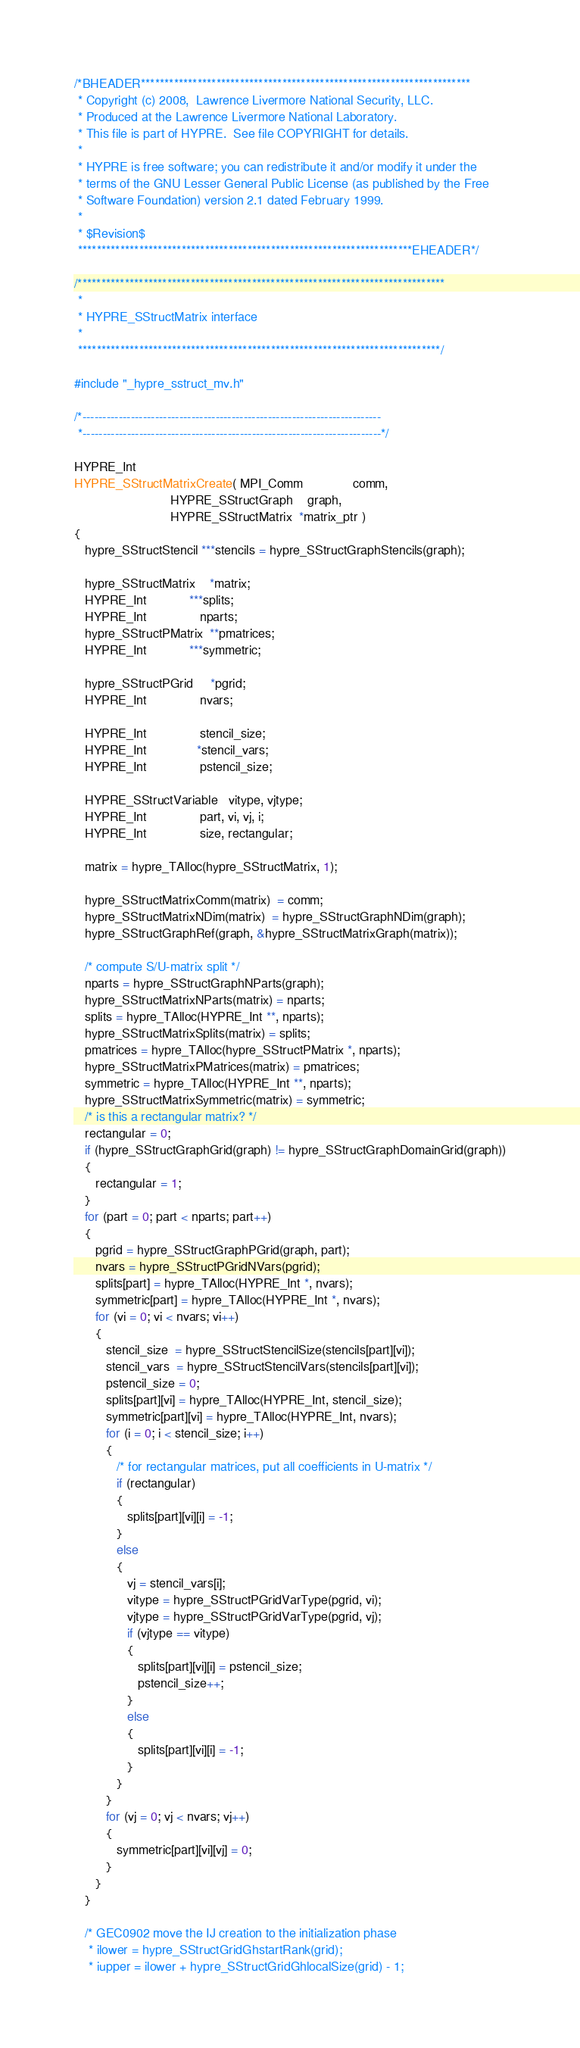Convert code to text. <code><loc_0><loc_0><loc_500><loc_500><_C_>/*BHEADER**********************************************************************
 * Copyright (c) 2008,  Lawrence Livermore National Security, LLC.
 * Produced at the Lawrence Livermore National Laboratory.
 * This file is part of HYPRE.  See file COPYRIGHT for details.
 *
 * HYPRE is free software; you can redistribute it and/or modify it under the
 * terms of the GNU Lesser General Public License (as published by the Free
 * Software Foundation) version 2.1 dated February 1999.
 *
 * $Revision$
 ***********************************************************************EHEADER*/

/******************************************************************************
 *
 * HYPRE_SStructMatrix interface
 *
 *****************************************************************************/

#include "_hypre_sstruct_mv.h"

/*--------------------------------------------------------------------------
 *--------------------------------------------------------------------------*/

HYPRE_Int
HYPRE_SStructMatrixCreate( MPI_Comm              comm,
                           HYPRE_SStructGraph    graph,
                           HYPRE_SStructMatrix  *matrix_ptr )
{
   hypre_SStructStencil ***stencils = hypre_SStructGraphStencils(graph);

   hypre_SStructMatrix    *matrix;
   HYPRE_Int            ***splits;
   HYPRE_Int               nparts;
   hypre_SStructPMatrix  **pmatrices;
   HYPRE_Int            ***symmetric;

   hypre_SStructPGrid     *pgrid;
   HYPRE_Int               nvars;

   HYPRE_Int               stencil_size;
   HYPRE_Int              *stencil_vars;
   HYPRE_Int               pstencil_size;

   HYPRE_SStructVariable   vitype, vjtype;
   HYPRE_Int               part, vi, vj, i;
   HYPRE_Int               size, rectangular;

   matrix = hypre_TAlloc(hypre_SStructMatrix, 1);

   hypre_SStructMatrixComm(matrix)  = comm;
   hypre_SStructMatrixNDim(matrix)  = hypre_SStructGraphNDim(graph);
   hypre_SStructGraphRef(graph, &hypre_SStructMatrixGraph(matrix));

   /* compute S/U-matrix split */
   nparts = hypre_SStructGraphNParts(graph);
   hypre_SStructMatrixNParts(matrix) = nparts;
   splits = hypre_TAlloc(HYPRE_Int **, nparts);
   hypre_SStructMatrixSplits(matrix) = splits;
   pmatrices = hypre_TAlloc(hypre_SStructPMatrix *, nparts);
   hypre_SStructMatrixPMatrices(matrix) = pmatrices;
   symmetric = hypre_TAlloc(HYPRE_Int **, nparts);
   hypre_SStructMatrixSymmetric(matrix) = symmetric;
   /* is this a rectangular matrix? */
   rectangular = 0;
   if (hypre_SStructGraphGrid(graph) != hypre_SStructGraphDomainGrid(graph))
   {
      rectangular = 1;
   }
   for (part = 0; part < nparts; part++)
   {
      pgrid = hypre_SStructGraphPGrid(graph, part);
      nvars = hypre_SStructPGridNVars(pgrid);
      splits[part] = hypre_TAlloc(HYPRE_Int *, nvars);
      symmetric[part] = hypre_TAlloc(HYPRE_Int *, nvars);
      for (vi = 0; vi < nvars; vi++)
      {
         stencil_size  = hypre_SStructStencilSize(stencils[part][vi]);
         stencil_vars  = hypre_SStructStencilVars(stencils[part][vi]);
         pstencil_size = 0;
         splits[part][vi] = hypre_TAlloc(HYPRE_Int, stencil_size);
         symmetric[part][vi] = hypre_TAlloc(HYPRE_Int, nvars);
         for (i = 0; i < stencil_size; i++)
         {
            /* for rectangular matrices, put all coefficients in U-matrix */
            if (rectangular)
            {
               splits[part][vi][i] = -1;
            }
            else
            {
               vj = stencil_vars[i];
               vitype = hypre_SStructPGridVarType(pgrid, vi);
               vjtype = hypre_SStructPGridVarType(pgrid, vj);
               if (vjtype == vitype)
               {
                  splits[part][vi][i] = pstencil_size;
                  pstencil_size++;
               }
               else
               {
                  splits[part][vi][i] = -1;
               }
            }
         }
         for (vj = 0; vj < nvars; vj++)
         {
            symmetric[part][vi][vj] = 0;
         }
      }
   }

   /* GEC0902 move the IJ creation to the initialization phase  
    * ilower = hypre_SStructGridGhstartRank(grid);
    * iupper = ilower + hypre_SStructGridGhlocalSize(grid) - 1; </code> 